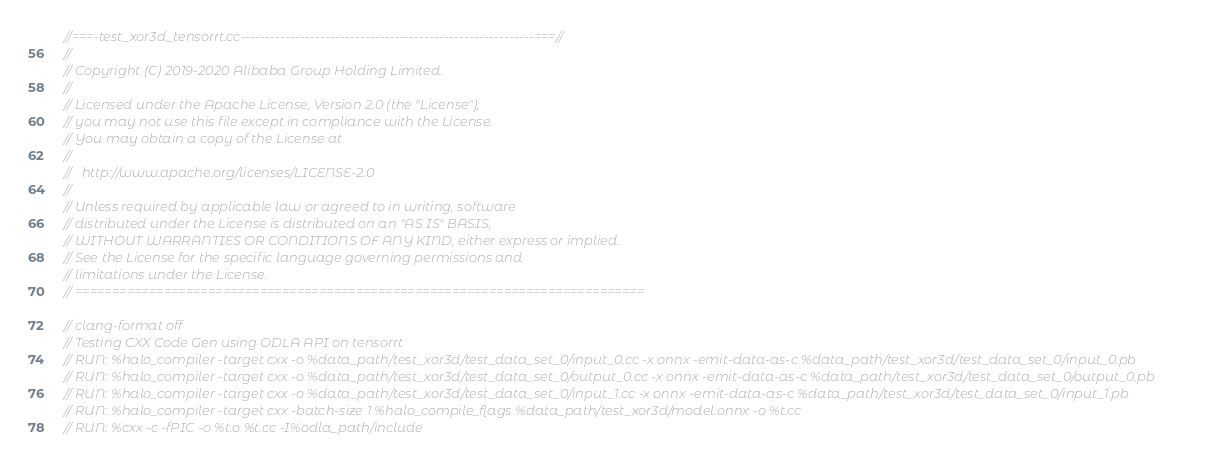Convert code to text. <code><loc_0><loc_0><loc_500><loc_500><_C++_>//===-test_xor3d_tensorrt.cc-----------------------------------------------------------===//
//
// Copyright (C) 2019-2020 Alibaba Group Holding Limited.
//
// Licensed under the Apache License, Version 2.0 (the "License");
// you may not use this file except in compliance with the License.
// You may obtain a copy of the License at
//
//   http://www.apache.org/licenses/LICENSE-2.0
//
// Unless required by applicable law or agreed to in writing, software
// distributed under the License is distributed on an "AS IS" BASIS,
// WITHOUT WARRANTIES OR CONDITIONS OF ANY KIND, either express or implied.
// See the License for the specific language governing permissions and
// limitations under the License.
// =============================================================================

// clang-format off
// Testing CXX Code Gen using ODLA API on tensorrt
// RUN: %halo_compiler -target cxx -o %data_path/test_xor3d/test_data_set_0/input_0.cc -x onnx -emit-data-as-c %data_path/test_xor3d/test_data_set_0/input_0.pb
// RUN: %halo_compiler -target cxx -o %data_path/test_xor3d/test_data_set_0/output_0.cc -x onnx -emit-data-as-c %data_path/test_xor3d/test_data_set_0/output_0.pb
// RUN: %halo_compiler -target cxx -o %data_path/test_xor3d/test_data_set_0/input_1.cc -x onnx -emit-data-as-c %data_path/test_xor3d/test_data_set_0/input_1.pb
// RUN: %halo_compiler -target cxx -batch-size 1 %halo_compile_flags %data_path/test_xor3d/model.onnx -o %t.cc
// RUN: %cxx -c -fPIC -o %t.o %t.cc -I%odla_path/include</code> 